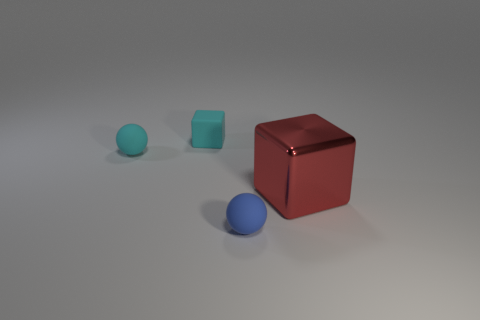Is there anything else that is the same size as the red object?
Provide a short and direct response. No. What size is the cyan rubber cube?
Provide a succinct answer. Small. Are there any blue matte things that have the same size as the cyan rubber block?
Offer a terse response. Yes. There is a rubber ball in front of the shiny object; is it the same size as the cyan cube that is on the left side of the blue thing?
Offer a terse response. Yes. Is there a large red object of the same shape as the tiny blue rubber thing?
Offer a very short reply. No. Is the number of big red things that are behind the tiny cyan matte cube the same as the number of large brown objects?
Keep it short and to the point. Yes. Is the size of the cyan ball the same as the cube on the right side of the blue ball?
Offer a terse response. No. How many small objects have the same material as the small cyan sphere?
Provide a succinct answer. 2. Is the blue rubber ball the same size as the matte block?
Your answer should be very brief. Yes. Is there any other thing that is the same color as the metallic cube?
Offer a terse response. No. 